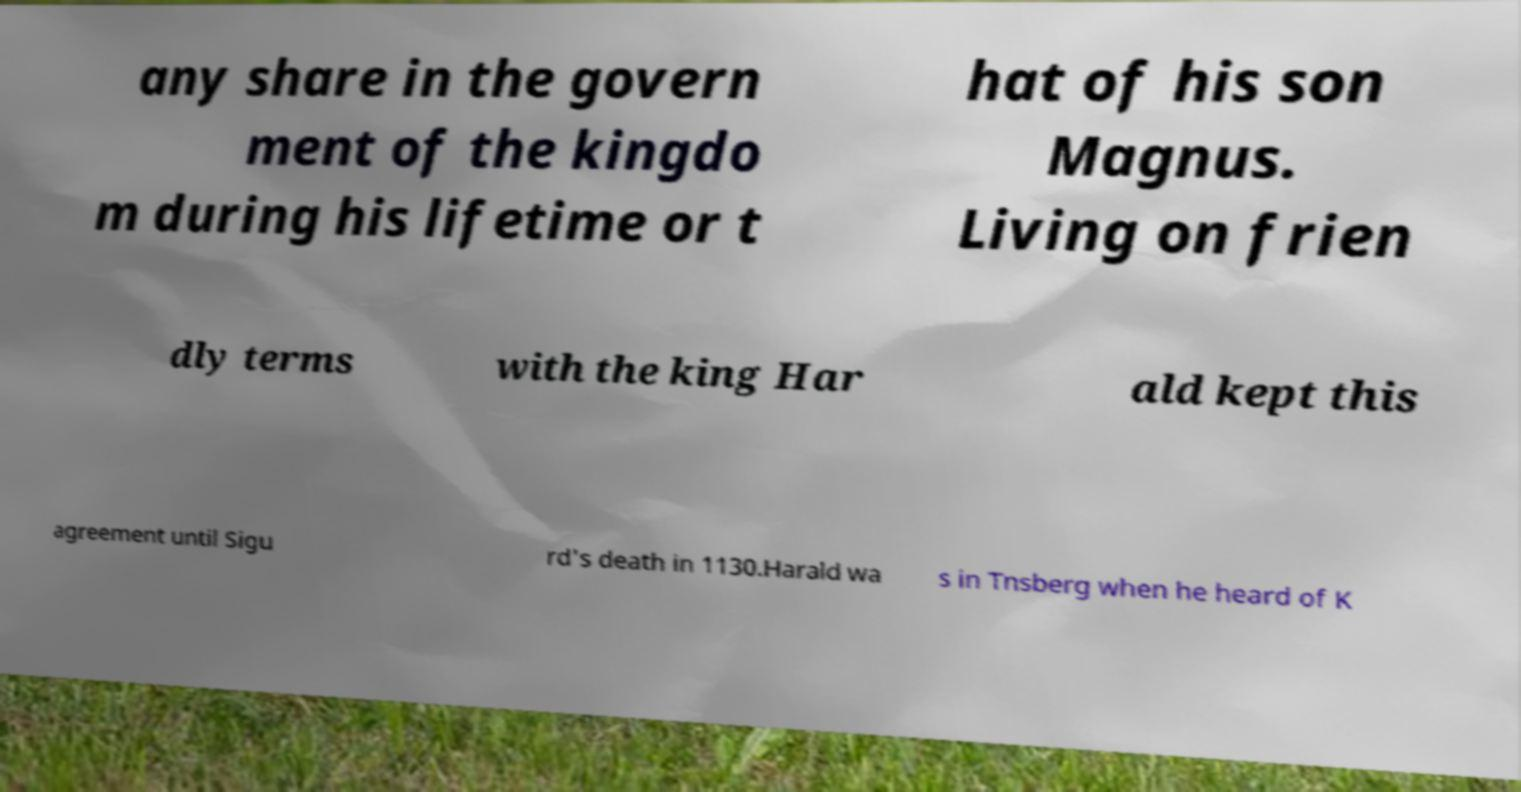Could you extract and type out the text from this image? any share in the govern ment of the kingdo m during his lifetime or t hat of his son Magnus. Living on frien dly terms with the king Har ald kept this agreement until Sigu rd's death in 1130.Harald wa s in Tnsberg when he heard of K 